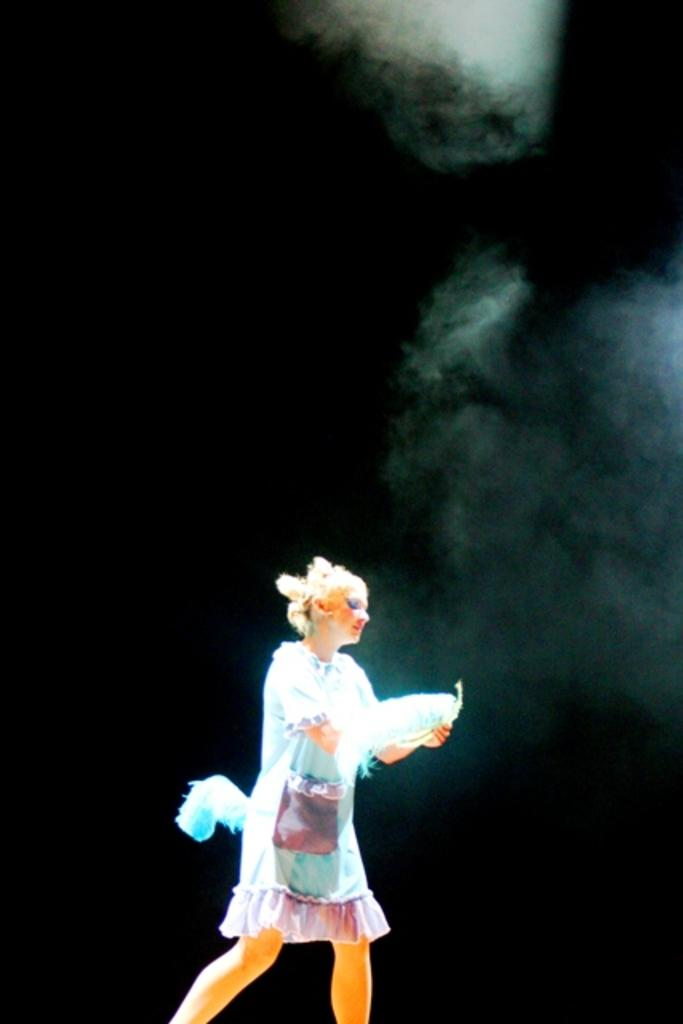Who is the main subject in the image? There is a woman in the image. What is the woman doing in the image? The woman is standing on the floor. What is the woman wearing in the image? The woman is wearing a dress. What object is the woman holding in the image? The woman is holding a feather in her hands. What type of salt is the woman using to season the dish in the image? There is no dish or salt present in the image; the woman is holding a feather. Who is the manager of the team in the image? There is no team or manager present in the image; the main subject is a woman holding a feather. 